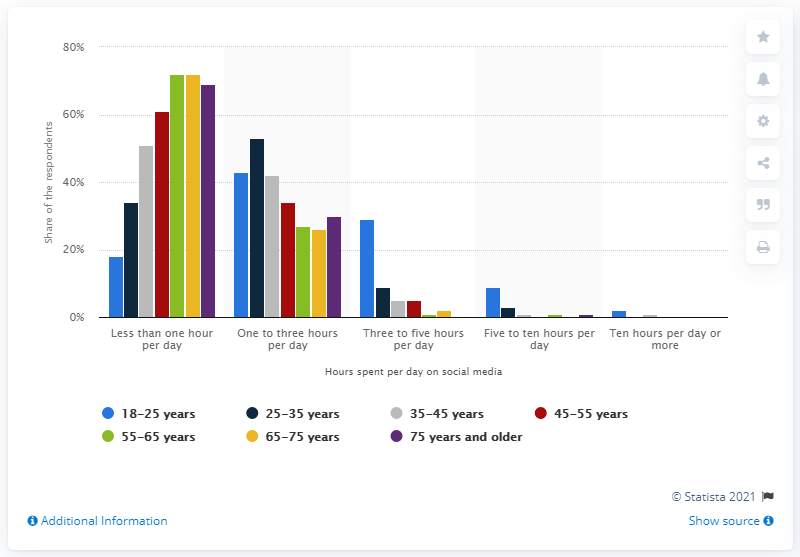Point out several critical features in this image. According to data, 30% of Dutch 18-to-25-year-olds spend three to five hours per day on social media. 